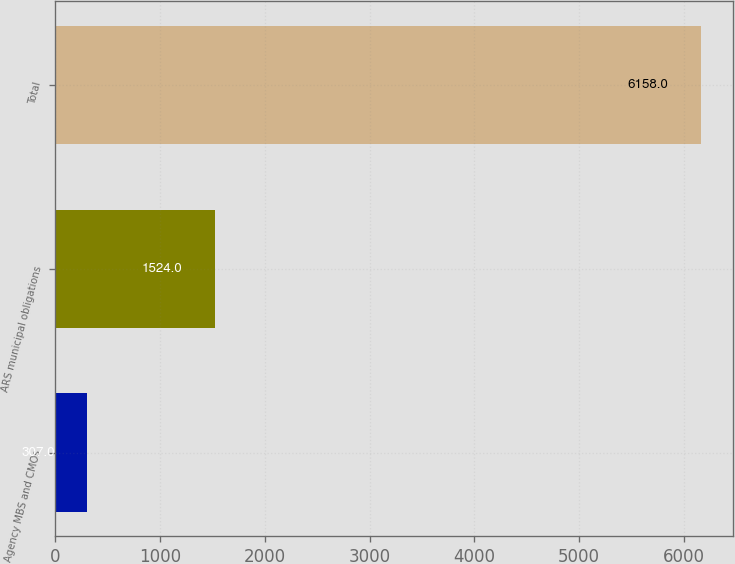Convert chart to OTSL. <chart><loc_0><loc_0><loc_500><loc_500><bar_chart><fcel>Agency MBS and CMOs<fcel>ARS municipal obligations<fcel>Total<nl><fcel>307<fcel>1524<fcel>6158<nl></chart> 